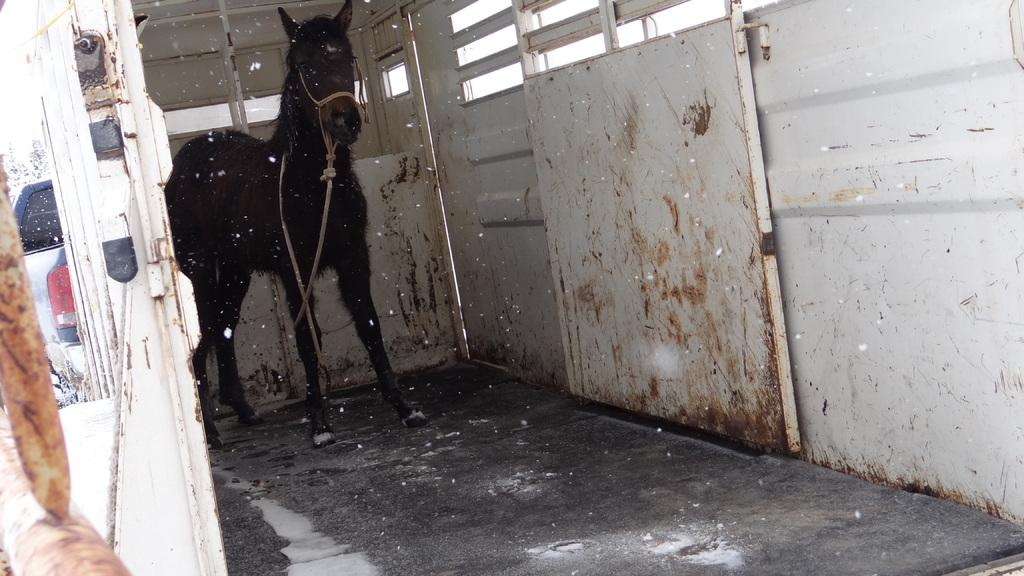What animal can be seen in the image? There is a horse in the image. How is the horse secured in the image? The horse is tied with a rope. What type of structure is on the right side of the image? There is a wall with a door on the right side of the image. What can be seen in the background of the image? There is a vehicle visible in the background of the image. What type of insurance policy is the horse covered under in the image? There is no information about insurance in the image; it only shows a horse tied with a rope and a wall with a door. What type of rake is being used to groom the horse in the image? There is no rake present in the image; it only shows a horse tied with a rope and a wall with a door. 